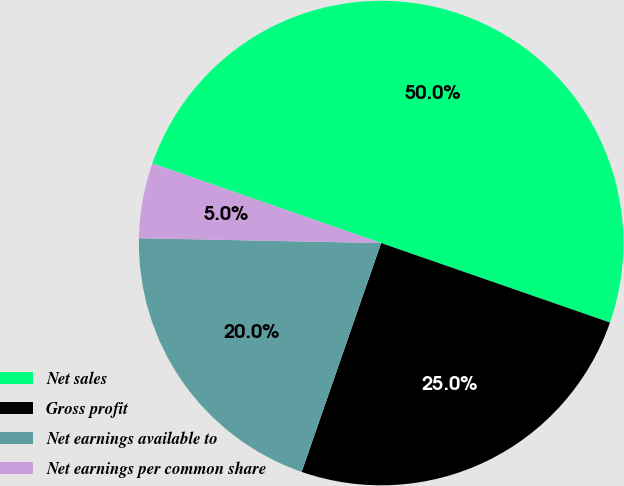<chart> <loc_0><loc_0><loc_500><loc_500><pie_chart><fcel>Net sales<fcel>Gross profit<fcel>Net earnings available to<fcel>Net earnings per common share<nl><fcel>49.99%<fcel>25.0%<fcel>20.0%<fcel>5.01%<nl></chart> 